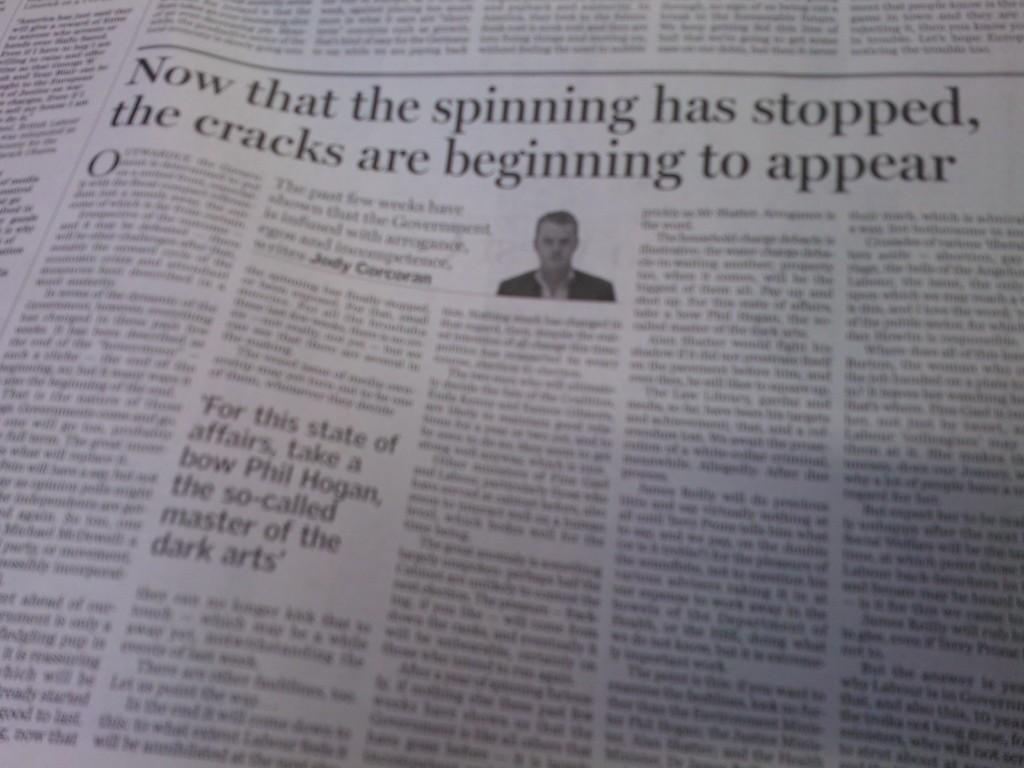How would you summarize this image in a sentence or two? This image is taken from the new paper. In this image there is an article. In the article there is a man and some text. 